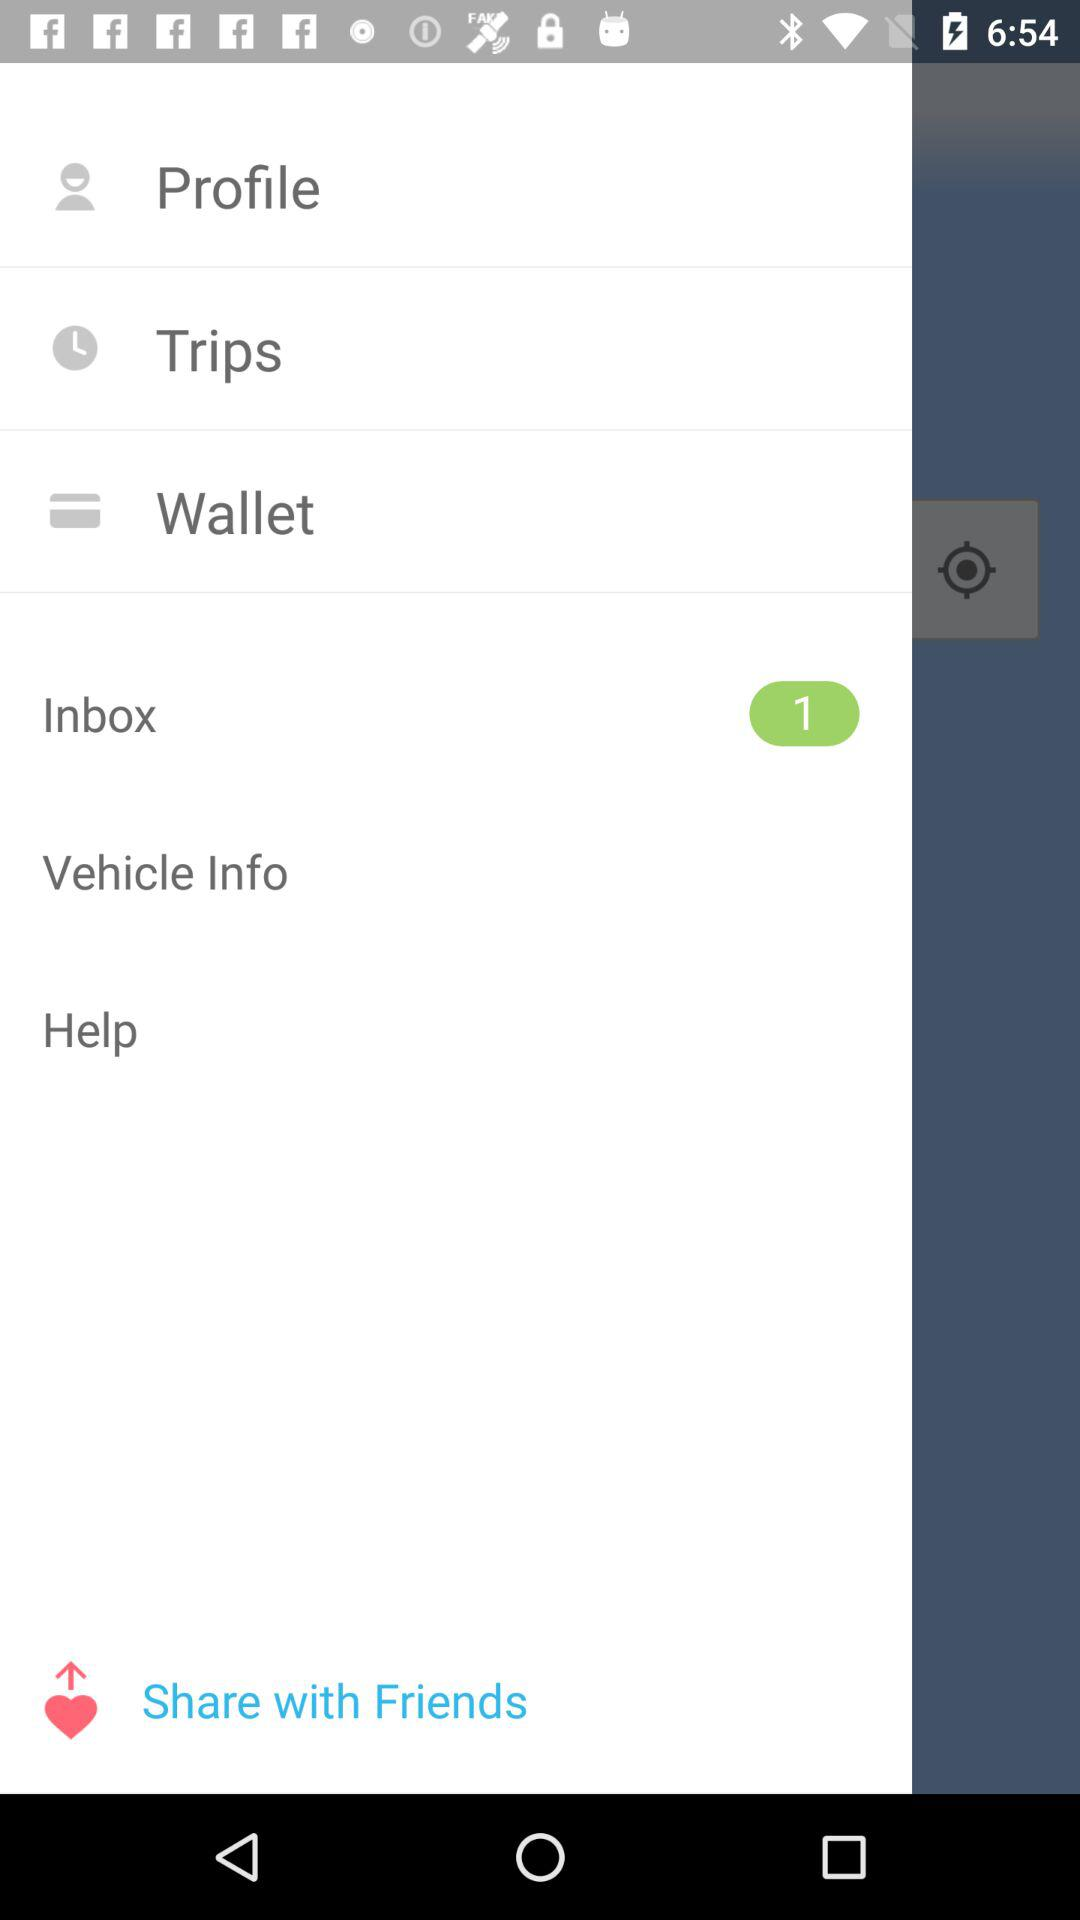Is there any unread message in the inbox? There is 1 unread message in the inbox. 